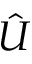Convert formula to latex. <formula><loc_0><loc_0><loc_500><loc_500>\hat { U }</formula> 